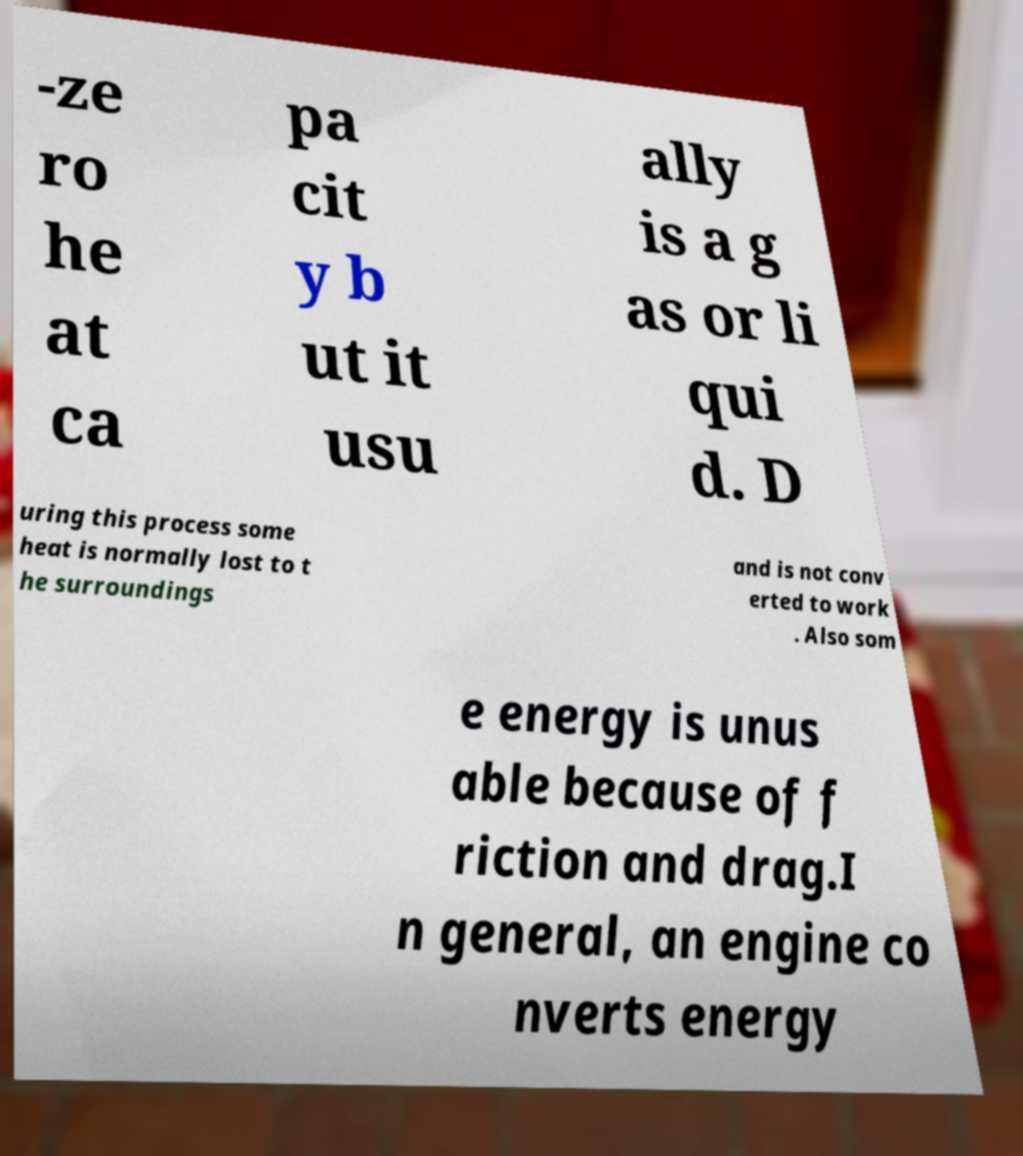Could you assist in decoding the text presented in this image and type it out clearly? -ze ro he at ca pa cit y b ut it usu ally is a g as or li qui d. D uring this process some heat is normally lost to t he surroundings and is not conv erted to work . Also som e energy is unus able because of f riction and drag.I n general, an engine co nverts energy 